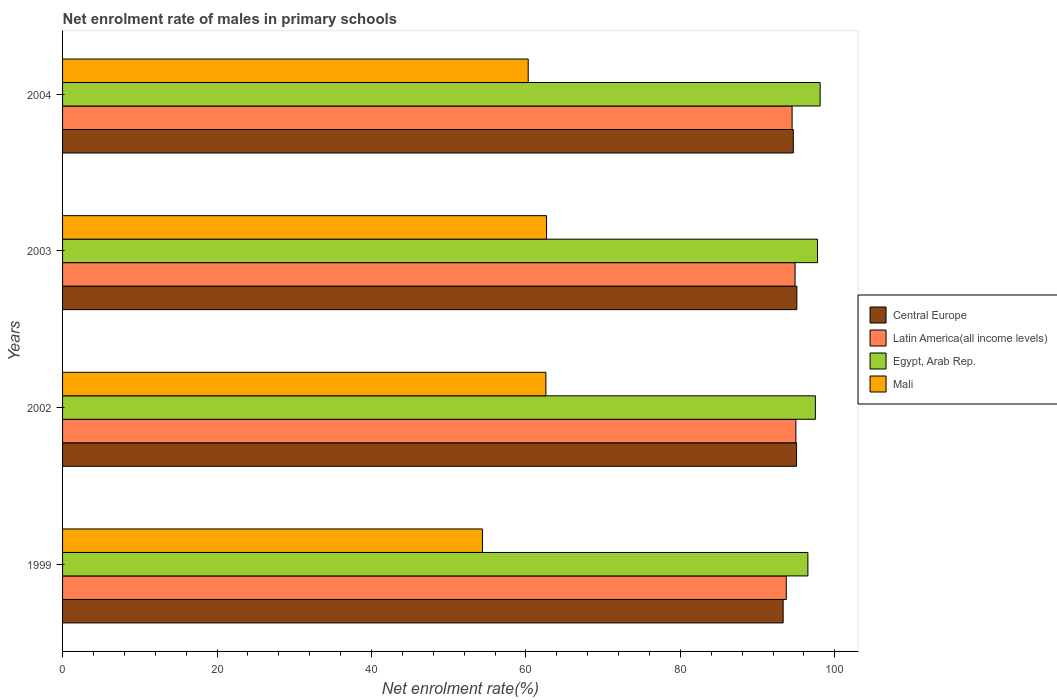How many different coloured bars are there?
Ensure brevity in your answer.  4. How many groups of bars are there?
Make the answer very short. 4. Are the number of bars on each tick of the Y-axis equal?
Provide a succinct answer. Yes. How many bars are there on the 1st tick from the top?
Provide a short and direct response. 4. What is the label of the 2nd group of bars from the top?
Your answer should be compact. 2003. What is the net enrolment rate of males in primary schools in Latin America(all income levels) in 2002?
Offer a terse response. 94.96. Across all years, what is the maximum net enrolment rate of males in primary schools in Latin America(all income levels)?
Make the answer very short. 94.96. Across all years, what is the minimum net enrolment rate of males in primary schools in Latin America(all income levels)?
Make the answer very short. 93.72. In which year was the net enrolment rate of males in primary schools in Egypt, Arab Rep. maximum?
Offer a terse response. 2004. What is the total net enrolment rate of males in primary schools in Mali in the graph?
Your answer should be very brief. 239.93. What is the difference between the net enrolment rate of males in primary schools in Central Europe in 1999 and that in 2003?
Your answer should be compact. -1.77. What is the difference between the net enrolment rate of males in primary schools in Latin America(all income levels) in 2003 and the net enrolment rate of males in primary schools in Mali in 2002?
Provide a succinct answer. 32.27. What is the average net enrolment rate of males in primary schools in Central Europe per year?
Give a very brief answer. 94.52. In the year 1999, what is the difference between the net enrolment rate of males in primary schools in Mali and net enrolment rate of males in primary schools in Central Europe?
Make the answer very short. -38.94. What is the ratio of the net enrolment rate of males in primary schools in Latin America(all income levels) in 2002 to that in 2003?
Offer a terse response. 1. Is the difference between the net enrolment rate of males in primary schools in Mali in 2002 and 2004 greater than the difference between the net enrolment rate of males in primary schools in Central Europe in 2002 and 2004?
Give a very brief answer. Yes. What is the difference between the highest and the second highest net enrolment rate of males in primary schools in Mali?
Provide a short and direct response. 0.09. What is the difference between the highest and the lowest net enrolment rate of males in primary schools in Mali?
Ensure brevity in your answer.  8.3. In how many years, is the net enrolment rate of males in primary schools in Mali greater than the average net enrolment rate of males in primary schools in Mali taken over all years?
Offer a very short reply. 3. Is it the case that in every year, the sum of the net enrolment rate of males in primary schools in Mali and net enrolment rate of males in primary schools in Latin America(all income levels) is greater than the sum of net enrolment rate of males in primary schools in Egypt, Arab Rep. and net enrolment rate of males in primary schools in Central Europe?
Your answer should be compact. No. What does the 2nd bar from the top in 2004 represents?
Your answer should be very brief. Egypt, Arab Rep. What does the 1st bar from the bottom in 2003 represents?
Your answer should be compact. Central Europe. Is it the case that in every year, the sum of the net enrolment rate of males in primary schools in Mali and net enrolment rate of males in primary schools in Latin America(all income levels) is greater than the net enrolment rate of males in primary schools in Egypt, Arab Rep.?
Keep it short and to the point. Yes. Are all the bars in the graph horizontal?
Keep it short and to the point. Yes. How many years are there in the graph?
Your response must be concise. 4. What is the difference between two consecutive major ticks on the X-axis?
Provide a short and direct response. 20. Does the graph contain any zero values?
Provide a short and direct response. No. How many legend labels are there?
Your answer should be very brief. 4. How are the legend labels stacked?
Offer a terse response. Vertical. What is the title of the graph?
Your answer should be compact. Net enrolment rate of males in primary schools. Does "Montenegro" appear as one of the legend labels in the graph?
Make the answer very short. No. What is the label or title of the X-axis?
Provide a short and direct response. Net enrolment rate(%). What is the Net enrolment rate(%) in Central Europe in 1999?
Your answer should be compact. 93.31. What is the Net enrolment rate(%) in Latin America(all income levels) in 1999?
Your answer should be compact. 93.72. What is the Net enrolment rate(%) of Egypt, Arab Rep. in 1999?
Your answer should be very brief. 96.52. What is the Net enrolment rate(%) of Mali in 1999?
Offer a terse response. 54.37. What is the Net enrolment rate(%) in Central Europe in 2002?
Keep it short and to the point. 95.05. What is the Net enrolment rate(%) in Latin America(all income levels) in 2002?
Your response must be concise. 94.96. What is the Net enrolment rate(%) in Egypt, Arab Rep. in 2002?
Make the answer very short. 97.48. What is the Net enrolment rate(%) in Mali in 2002?
Provide a short and direct response. 62.59. What is the Net enrolment rate(%) of Central Europe in 2003?
Offer a very short reply. 95.09. What is the Net enrolment rate(%) in Latin America(all income levels) in 2003?
Provide a succinct answer. 94.85. What is the Net enrolment rate(%) in Egypt, Arab Rep. in 2003?
Your answer should be compact. 97.76. What is the Net enrolment rate(%) in Mali in 2003?
Your answer should be very brief. 62.67. What is the Net enrolment rate(%) of Central Europe in 2004?
Provide a short and direct response. 94.63. What is the Net enrolment rate(%) of Latin America(all income levels) in 2004?
Your answer should be very brief. 94.47. What is the Net enrolment rate(%) of Egypt, Arab Rep. in 2004?
Your answer should be compact. 98.1. What is the Net enrolment rate(%) of Mali in 2004?
Offer a terse response. 60.3. Across all years, what is the maximum Net enrolment rate(%) in Central Europe?
Keep it short and to the point. 95.09. Across all years, what is the maximum Net enrolment rate(%) of Latin America(all income levels)?
Your answer should be very brief. 94.96. Across all years, what is the maximum Net enrolment rate(%) of Egypt, Arab Rep.?
Your response must be concise. 98.1. Across all years, what is the maximum Net enrolment rate(%) in Mali?
Offer a very short reply. 62.67. Across all years, what is the minimum Net enrolment rate(%) of Central Europe?
Your answer should be compact. 93.31. Across all years, what is the minimum Net enrolment rate(%) in Latin America(all income levels)?
Give a very brief answer. 93.72. Across all years, what is the minimum Net enrolment rate(%) of Egypt, Arab Rep.?
Give a very brief answer. 96.52. Across all years, what is the minimum Net enrolment rate(%) of Mali?
Provide a succinct answer. 54.37. What is the total Net enrolment rate(%) in Central Europe in the graph?
Give a very brief answer. 378.08. What is the total Net enrolment rate(%) of Latin America(all income levels) in the graph?
Keep it short and to the point. 378.01. What is the total Net enrolment rate(%) of Egypt, Arab Rep. in the graph?
Offer a terse response. 389.87. What is the total Net enrolment rate(%) in Mali in the graph?
Give a very brief answer. 239.93. What is the difference between the Net enrolment rate(%) of Central Europe in 1999 and that in 2002?
Provide a succinct answer. -1.74. What is the difference between the Net enrolment rate(%) in Latin America(all income levels) in 1999 and that in 2002?
Your answer should be compact. -1.24. What is the difference between the Net enrolment rate(%) in Egypt, Arab Rep. in 1999 and that in 2002?
Provide a short and direct response. -0.97. What is the difference between the Net enrolment rate(%) of Mali in 1999 and that in 2002?
Keep it short and to the point. -8.21. What is the difference between the Net enrolment rate(%) in Central Europe in 1999 and that in 2003?
Provide a succinct answer. -1.77. What is the difference between the Net enrolment rate(%) of Latin America(all income levels) in 1999 and that in 2003?
Make the answer very short. -1.14. What is the difference between the Net enrolment rate(%) in Egypt, Arab Rep. in 1999 and that in 2003?
Your answer should be compact. -1.25. What is the difference between the Net enrolment rate(%) in Mali in 1999 and that in 2003?
Ensure brevity in your answer.  -8.3. What is the difference between the Net enrolment rate(%) in Central Europe in 1999 and that in 2004?
Keep it short and to the point. -1.32. What is the difference between the Net enrolment rate(%) of Latin America(all income levels) in 1999 and that in 2004?
Provide a succinct answer. -0.75. What is the difference between the Net enrolment rate(%) in Egypt, Arab Rep. in 1999 and that in 2004?
Ensure brevity in your answer.  -1.59. What is the difference between the Net enrolment rate(%) in Mali in 1999 and that in 2004?
Provide a short and direct response. -5.93. What is the difference between the Net enrolment rate(%) in Central Europe in 2002 and that in 2003?
Make the answer very short. -0.03. What is the difference between the Net enrolment rate(%) of Latin America(all income levels) in 2002 and that in 2003?
Make the answer very short. 0.11. What is the difference between the Net enrolment rate(%) of Egypt, Arab Rep. in 2002 and that in 2003?
Offer a very short reply. -0.28. What is the difference between the Net enrolment rate(%) in Mali in 2002 and that in 2003?
Offer a terse response. -0.09. What is the difference between the Net enrolment rate(%) of Central Europe in 2002 and that in 2004?
Your answer should be compact. 0.42. What is the difference between the Net enrolment rate(%) in Latin America(all income levels) in 2002 and that in 2004?
Offer a terse response. 0.49. What is the difference between the Net enrolment rate(%) in Egypt, Arab Rep. in 2002 and that in 2004?
Offer a terse response. -0.62. What is the difference between the Net enrolment rate(%) in Mali in 2002 and that in 2004?
Offer a terse response. 2.29. What is the difference between the Net enrolment rate(%) of Central Europe in 2003 and that in 2004?
Provide a short and direct response. 0.46. What is the difference between the Net enrolment rate(%) of Latin America(all income levels) in 2003 and that in 2004?
Give a very brief answer. 0.38. What is the difference between the Net enrolment rate(%) of Egypt, Arab Rep. in 2003 and that in 2004?
Provide a succinct answer. -0.34. What is the difference between the Net enrolment rate(%) in Mali in 2003 and that in 2004?
Ensure brevity in your answer.  2.37. What is the difference between the Net enrolment rate(%) of Central Europe in 1999 and the Net enrolment rate(%) of Latin America(all income levels) in 2002?
Make the answer very short. -1.65. What is the difference between the Net enrolment rate(%) of Central Europe in 1999 and the Net enrolment rate(%) of Egypt, Arab Rep. in 2002?
Provide a short and direct response. -4.17. What is the difference between the Net enrolment rate(%) in Central Europe in 1999 and the Net enrolment rate(%) in Mali in 2002?
Keep it short and to the point. 30.73. What is the difference between the Net enrolment rate(%) in Latin America(all income levels) in 1999 and the Net enrolment rate(%) in Egypt, Arab Rep. in 2002?
Your answer should be compact. -3.76. What is the difference between the Net enrolment rate(%) in Latin America(all income levels) in 1999 and the Net enrolment rate(%) in Mali in 2002?
Offer a terse response. 31.13. What is the difference between the Net enrolment rate(%) in Egypt, Arab Rep. in 1999 and the Net enrolment rate(%) in Mali in 2002?
Your response must be concise. 33.93. What is the difference between the Net enrolment rate(%) in Central Europe in 1999 and the Net enrolment rate(%) in Latin America(all income levels) in 2003?
Make the answer very short. -1.54. What is the difference between the Net enrolment rate(%) of Central Europe in 1999 and the Net enrolment rate(%) of Egypt, Arab Rep. in 2003?
Your response must be concise. -4.45. What is the difference between the Net enrolment rate(%) in Central Europe in 1999 and the Net enrolment rate(%) in Mali in 2003?
Give a very brief answer. 30.64. What is the difference between the Net enrolment rate(%) in Latin America(all income levels) in 1999 and the Net enrolment rate(%) in Egypt, Arab Rep. in 2003?
Offer a very short reply. -4.04. What is the difference between the Net enrolment rate(%) in Latin America(all income levels) in 1999 and the Net enrolment rate(%) in Mali in 2003?
Offer a very short reply. 31.05. What is the difference between the Net enrolment rate(%) of Egypt, Arab Rep. in 1999 and the Net enrolment rate(%) of Mali in 2003?
Give a very brief answer. 33.84. What is the difference between the Net enrolment rate(%) in Central Europe in 1999 and the Net enrolment rate(%) in Latin America(all income levels) in 2004?
Offer a terse response. -1.16. What is the difference between the Net enrolment rate(%) of Central Europe in 1999 and the Net enrolment rate(%) of Egypt, Arab Rep. in 2004?
Your response must be concise. -4.79. What is the difference between the Net enrolment rate(%) in Central Europe in 1999 and the Net enrolment rate(%) in Mali in 2004?
Provide a succinct answer. 33.01. What is the difference between the Net enrolment rate(%) of Latin America(all income levels) in 1999 and the Net enrolment rate(%) of Egypt, Arab Rep. in 2004?
Your response must be concise. -4.38. What is the difference between the Net enrolment rate(%) in Latin America(all income levels) in 1999 and the Net enrolment rate(%) in Mali in 2004?
Your response must be concise. 33.42. What is the difference between the Net enrolment rate(%) of Egypt, Arab Rep. in 1999 and the Net enrolment rate(%) of Mali in 2004?
Your answer should be compact. 36.22. What is the difference between the Net enrolment rate(%) in Central Europe in 2002 and the Net enrolment rate(%) in Latin America(all income levels) in 2003?
Provide a short and direct response. 0.2. What is the difference between the Net enrolment rate(%) in Central Europe in 2002 and the Net enrolment rate(%) in Egypt, Arab Rep. in 2003?
Your answer should be compact. -2.71. What is the difference between the Net enrolment rate(%) of Central Europe in 2002 and the Net enrolment rate(%) of Mali in 2003?
Keep it short and to the point. 32.38. What is the difference between the Net enrolment rate(%) in Latin America(all income levels) in 2002 and the Net enrolment rate(%) in Egypt, Arab Rep. in 2003?
Provide a short and direct response. -2.8. What is the difference between the Net enrolment rate(%) of Latin America(all income levels) in 2002 and the Net enrolment rate(%) of Mali in 2003?
Give a very brief answer. 32.29. What is the difference between the Net enrolment rate(%) of Egypt, Arab Rep. in 2002 and the Net enrolment rate(%) of Mali in 2003?
Provide a short and direct response. 34.81. What is the difference between the Net enrolment rate(%) in Central Europe in 2002 and the Net enrolment rate(%) in Latin America(all income levels) in 2004?
Offer a terse response. 0.58. What is the difference between the Net enrolment rate(%) in Central Europe in 2002 and the Net enrolment rate(%) in Egypt, Arab Rep. in 2004?
Provide a succinct answer. -3.05. What is the difference between the Net enrolment rate(%) of Central Europe in 2002 and the Net enrolment rate(%) of Mali in 2004?
Give a very brief answer. 34.75. What is the difference between the Net enrolment rate(%) of Latin America(all income levels) in 2002 and the Net enrolment rate(%) of Egypt, Arab Rep. in 2004?
Keep it short and to the point. -3.14. What is the difference between the Net enrolment rate(%) of Latin America(all income levels) in 2002 and the Net enrolment rate(%) of Mali in 2004?
Give a very brief answer. 34.66. What is the difference between the Net enrolment rate(%) of Egypt, Arab Rep. in 2002 and the Net enrolment rate(%) of Mali in 2004?
Offer a very short reply. 37.19. What is the difference between the Net enrolment rate(%) of Central Europe in 2003 and the Net enrolment rate(%) of Latin America(all income levels) in 2004?
Keep it short and to the point. 0.62. What is the difference between the Net enrolment rate(%) in Central Europe in 2003 and the Net enrolment rate(%) in Egypt, Arab Rep. in 2004?
Give a very brief answer. -3.02. What is the difference between the Net enrolment rate(%) in Central Europe in 2003 and the Net enrolment rate(%) in Mali in 2004?
Keep it short and to the point. 34.79. What is the difference between the Net enrolment rate(%) of Latin America(all income levels) in 2003 and the Net enrolment rate(%) of Egypt, Arab Rep. in 2004?
Your answer should be very brief. -3.25. What is the difference between the Net enrolment rate(%) in Latin America(all income levels) in 2003 and the Net enrolment rate(%) in Mali in 2004?
Make the answer very short. 34.56. What is the difference between the Net enrolment rate(%) in Egypt, Arab Rep. in 2003 and the Net enrolment rate(%) in Mali in 2004?
Ensure brevity in your answer.  37.47. What is the average Net enrolment rate(%) of Central Europe per year?
Provide a short and direct response. 94.52. What is the average Net enrolment rate(%) in Latin America(all income levels) per year?
Offer a very short reply. 94.5. What is the average Net enrolment rate(%) of Egypt, Arab Rep. per year?
Keep it short and to the point. 97.47. What is the average Net enrolment rate(%) of Mali per year?
Your response must be concise. 59.98. In the year 1999, what is the difference between the Net enrolment rate(%) in Central Europe and Net enrolment rate(%) in Latin America(all income levels)?
Provide a short and direct response. -0.41. In the year 1999, what is the difference between the Net enrolment rate(%) of Central Europe and Net enrolment rate(%) of Egypt, Arab Rep.?
Offer a very short reply. -3.2. In the year 1999, what is the difference between the Net enrolment rate(%) of Central Europe and Net enrolment rate(%) of Mali?
Your response must be concise. 38.94. In the year 1999, what is the difference between the Net enrolment rate(%) of Latin America(all income levels) and Net enrolment rate(%) of Egypt, Arab Rep.?
Your answer should be compact. -2.8. In the year 1999, what is the difference between the Net enrolment rate(%) of Latin America(all income levels) and Net enrolment rate(%) of Mali?
Your answer should be compact. 39.35. In the year 1999, what is the difference between the Net enrolment rate(%) of Egypt, Arab Rep. and Net enrolment rate(%) of Mali?
Make the answer very short. 42.14. In the year 2002, what is the difference between the Net enrolment rate(%) in Central Europe and Net enrolment rate(%) in Latin America(all income levels)?
Your answer should be compact. 0.09. In the year 2002, what is the difference between the Net enrolment rate(%) in Central Europe and Net enrolment rate(%) in Egypt, Arab Rep.?
Provide a short and direct response. -2.43. In the year 2002, what is the difference between the Net enrolment rate(%) in Central Europe and Net enrolment rate(%) in Mali?
Your answer should be very brief. 32.47. In the year 2002, what is the difference between the Net enrolment rate(%) in Latin America(all income levels) and Net enrolment rate(%) in Egypt, Arab Rep.?
Keep it short and to the point. -2.52. In the year 2002, what is the difference between the Net enrolment rate(%) of Latin America(all income levels) and Net enrolment rate(%) of Mali?
Offer a very short reply. 32.37. In the year 2002, what is the difference between the Net enrolment rate(%) of Egypt, Arab Rep. and Net enrolment rate(%) of Mali?
Offer a very short reply. 34.9. In the year 2003, what is the difference between the Net enrolment rate(%) in Central Europe and Net enrolment rate(%) in Latin America(all income levels)?
Provide a succinct answer. 0.23. In the year 2003, what is the difference between the Net enrolment rate(%) in Central Europe and Net enrolment rate(%) in Egypt, Arab Rep.?
Your answer should be very brief. -2.68. In the year 2003, what is the difference between the Net enrolment rate(%) of Central Europe and Net enrolment rate(%) of Mali?
Your answer should be very brief. 32.42. In the year 2003, what is the difference between the Net enrolment rate(%) of Latin America(all income levels) and Net enrolment rate(%) of Egypt, Arab Rep.?
Give a very brief answer. -2.91. In the year 2003, what is the difference between the Net enrolment rate(%) of Latin America(all income levels) and Net enrolment rate(%) of Mali?
Offer a terse response. 32.18. In the year 2003, what is the difference between the Net enrolment rate(%) of Egypt, Arab Rep. and Net enrolment rate(%) of Mali?
Offer a terse response. 35.09. In the year 2004, what is the difference between the Net enrolment rate(%) of Central Europe and Net enrolment rate(%) of Latin America(all income levels)?
Provide a short and direct response. 0.16. In the year 2004, what is the difference between the Net enrolment rate(%) in Central Europe and Net enrolment rate(%) in Egypt, Arab Rep.?
Offer a very short reply. -3.48. In the year 2004, what is the difference between the Net enrolment rate(%) of Central Europe and Net enrolment rate(%) of Mali?
Offer a terse response. 34.33. In the year 2004, what is the difference between the Net enrolment rate(%) of Latin America(all income levels) and Net enrolment rate(%) of Egypt, Arab Rep.?
Provide a short and direct response. -3.63. In the year 2004, what is the difference between the Net enrolment rate(%) in Latin America(all income levels) and Net enrolment rate(%) in Mali?
Keep it short and to the point. 34.17. In the year 2004, what is the difference between the Net enrolment rate(%) of Egypt, Arab Rep. and Net enrolment rate(%) of Mali?
Provide a short and direct response. 37.81. What is the ratio of the Net enrolment rate(%) of Central Europe in 1999 to that in 2002?
Keep it short and to the point. 0.98. What is the ratio of the Net enrolment rate(%) of Latin America(all income levels) in 1999 to that in 2002?
Provide a succinct answer. 0.99. What is the ratio of the Net enrolment rate(%) of Egypt, Arab Rep. in 1999 to that in 2002?
Give a very brief answer. 0.99. What is the ratio of the Net enrolment rate(%) in Mali in 1999 to that in 2002?
Offer a very short reply. 0.87. What is the ratio of the Net enrolment rate(%) in Central Europe in 1999 to that in 2003?
Provide a short and direct response. 0.98. What is the ratio of the Net enrolment rate(%) in Latin America(all income levels) in 1999 to that in 2003?
Offer a very short reply. 0.99. What is the ratio of the Net enrolment rate(%) in Egypt, Arab Rep. in 1999 to that in 2003?
Offer a very short reply. 0.99. What is the ratio of the Net enrolment rate(%) in Mali in 1999 to that in 2003?
Provide a short and direct response. 0.87. What is the ratio of the Net enrolment rate(%) of Central Europe in 1999 to that in 2004?
Give a very brief answer. 0.99. What is the ratio of the Net enrolment rate(%) in Egypt, Arab Rep. in 1999 to that in 2004?
Give a very brief answer. 0.98. What is the ratio of the Net enrolment rate(%) of Mali in 1999 to that in 2004?
Offer a very short reply. 0.9. What is the ratio of the Net enrolment rate(%) in Central Europe in 2002 to that in 2003?
Give a very brief answer. 1. What is the ratio of the Net enrolment rate(%) of Central Europe in 2002 to that in 2004?
Give a very brief answer. 1. What is the ratio of the Net enrolment rate(%) in Latin America(all income levels) in 2002 to that in 2004?
Ensure brevity in your answer.  1.01. What is the ratio of the Net enrolment rate(%) of Egypt, Arab Rep. in 2002 to that in 2004?
Keep it short and to the point. 0.99. What is the ratio of the Net enrolment rate(%) in Mali in 2002 to that in 2004?
Offer a very short reply. 1.04. What is the ratio of the Net enrolment rate(%) in Central Europe in 2003 to that in 2004?
Offer a terse response. 1. What is the ratio of the Net enrolment rate(%) of Mali in 2003 to that in 2004?
Provide a short and direct response. 1.04. What is the difference between the highest and the second highest Net enrolment rate(%) of Central Europe?
Your answer should be very brief. 0.03. What is the difference between the highest and the second highest Net enrolment rate(%) in Latin America(all income levels)?
Ensure brevity in your answer.  0.11. What is the difference between the highest and the second highest Net enrolment rate(%) of Egypt, Arab Rep.?
Provide a short and direct response. 0.34. What is the difference between the highest and the second highest Net enrolment rate(%) in Mali?
Ensure brevity in your answer.  0.09. What is the difference between the highest and the lowest Net enrolment rate(%) in Central Europe?
Make the answer very short. 1.77. What is the difference between the highest and the lowest Net enrolment rate(%) in Latin America(all income levels)?
Give a very brief answer. 1.24. What is the difference between the highest and the lowest Net enrolment rate(%) in Egypt, Arab Rep.?
Provide a short and direct response. 1.59. What is the difference between the highest and the lowest Net enrolment rate(%) of Mali?
Your answer should be very brief. 8.3. 